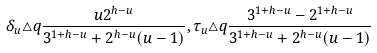Convert formula to latex. <formula><loc_0><loc_0><loc_500><loc_500>\delta _ { u } \triangle q \frac { u 2 ^ { h - u } } { 3 ^ { 1 + h - u } + 2 ^ { h - u } ( u - 1 ) } , \tau _ { u } \triangle q \frac { 3 ^ { 1 + h - u } - 2 ^ { 1 + h - u } } { 3 ^ { 1 + h - u } + 2 ^ { h - u } ( u - 1 ) }</formula> 